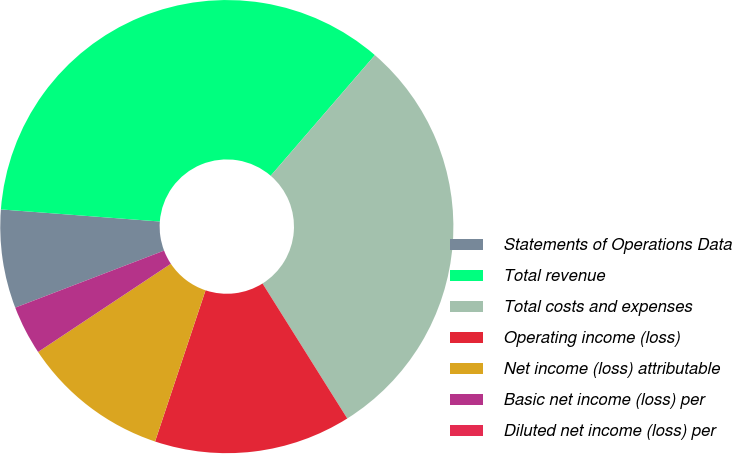Convert chart to OTSL. <chart><loc_0><loc_0><loc_500><loc_500><pie_chart><fcel>Statements of Operations Data<fcel>Total revenue<fcel>Total costs and expenses<fcel>Operating income (loss)<fcel>Net income (loss) attributable<fcel>Basic net income (loss) per<fcel>Diluted net income (loss) per<nl><fcel>7.03%<fcel>35.13%<fcel>29.74%<fcel>14.05%<fcel>10.54%<fcel>3.51%<fcel>0.0%<nl></chart> 